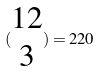<formula> <loc_0><loc_0><loc_500><loc_500>( \begin{matrix} 1 2 \\ 3 \end{matrix} ) = 2 2 0</formula> 